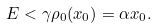Convert formula to latex. <formula><loc_0><loc_0><loc_500><loc_500>E < \gamma \rho _ { 0 } ( x _ { 0 } ) = \alpha x _ { 0 } .</formula> 